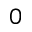Convert formula to latex. <formula><loc_0><loc_0><loc_500><loc_500>0</formula> 